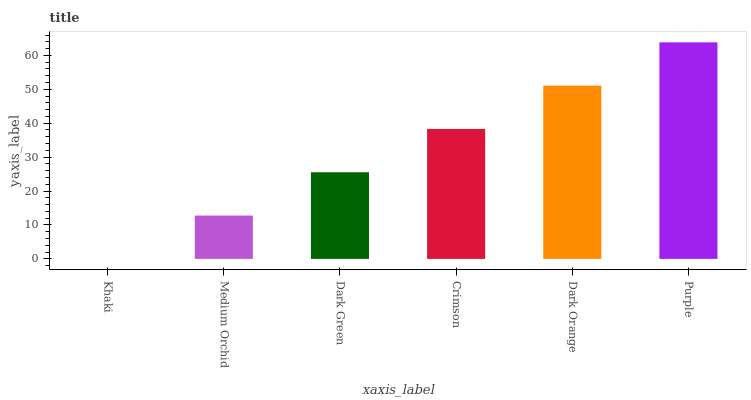Is Medium Orchid the minimum?
Answer yes or no. No. Is Medium Orchid the maximum?
Answer yes or no. No. Is Medium Orchid greater than Khaki?
Answer yes or no. Yes. Is Khaki less than Medium Orchid?
Answer yes or no. Yes. Is Khaki greater than Medium Orchid?
Answer yes or no. No. Is Medium Orchid less than Khaki?
Answer yes or no. No. Is Crimson the high median?
Answer yes or no. Yes. Is Dark Green the low median?
Answer yes or no. Yes. Is Medium Orchid the high median?
Answer yes or no. No. Is Purple the low median?
Answer yes or no. No. 